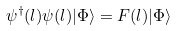<formula> <loc_0><loc_0><loc_500><loc_500>\psi ^ { \dagger } ( l ) \psi ( l ) | \Phi \rangle = F ( l ) | \Phi \rangle</formula> 